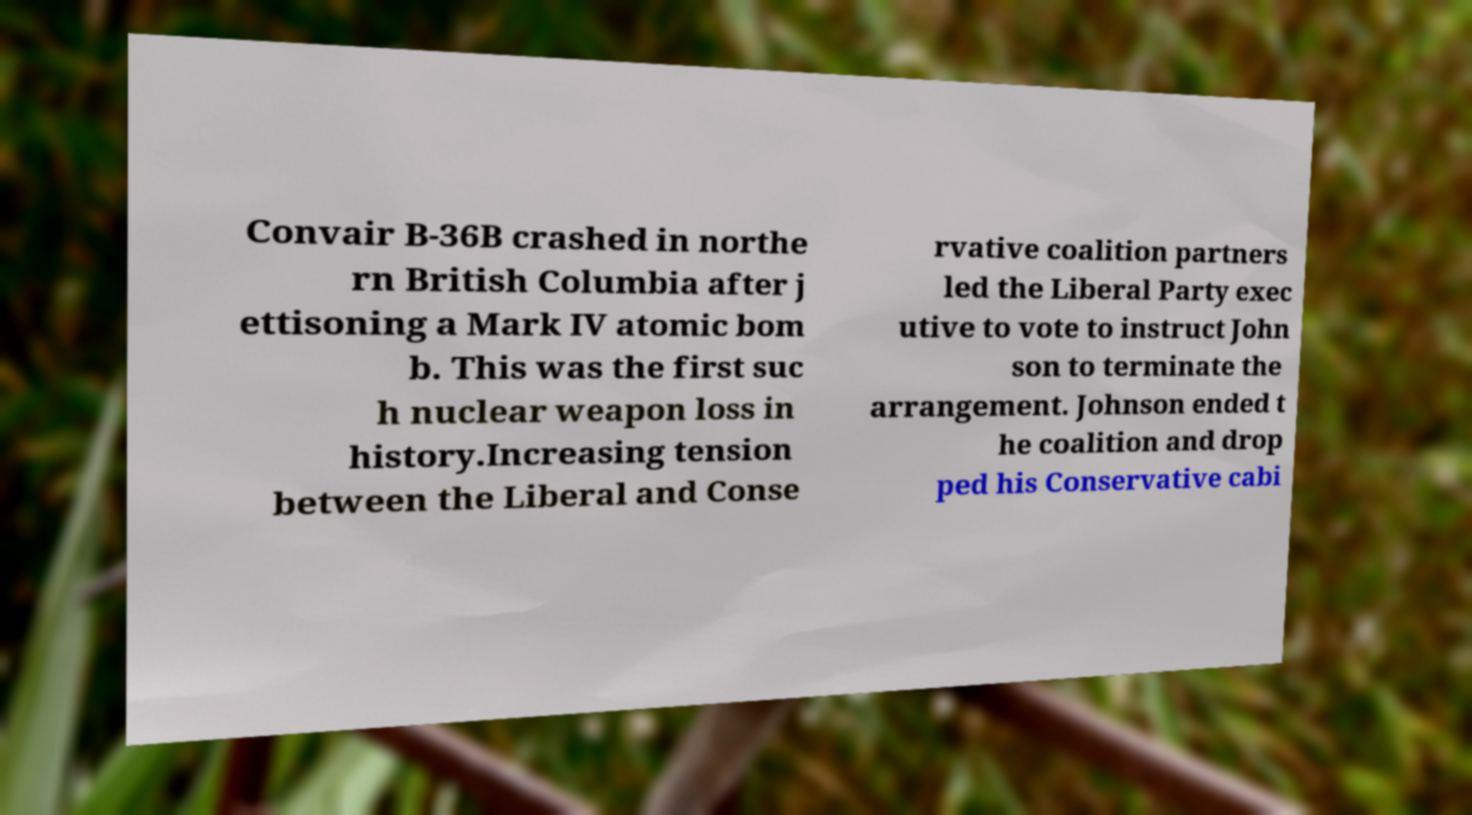Please identify and transcribe the text found in this image. Convair B-36B crashed in northe rn British Columbia after j ettisoning a Mark IV atomic bom b. This was the first suc h nuclear weapon loss in history.Increasing tension between the Liberal and Conse rvative coalition partners led the Liberal Party exec utive to vote to instruct John son to terminate the arrangement. Johnson ended t he coalition and drop ped his Conservative cabi 